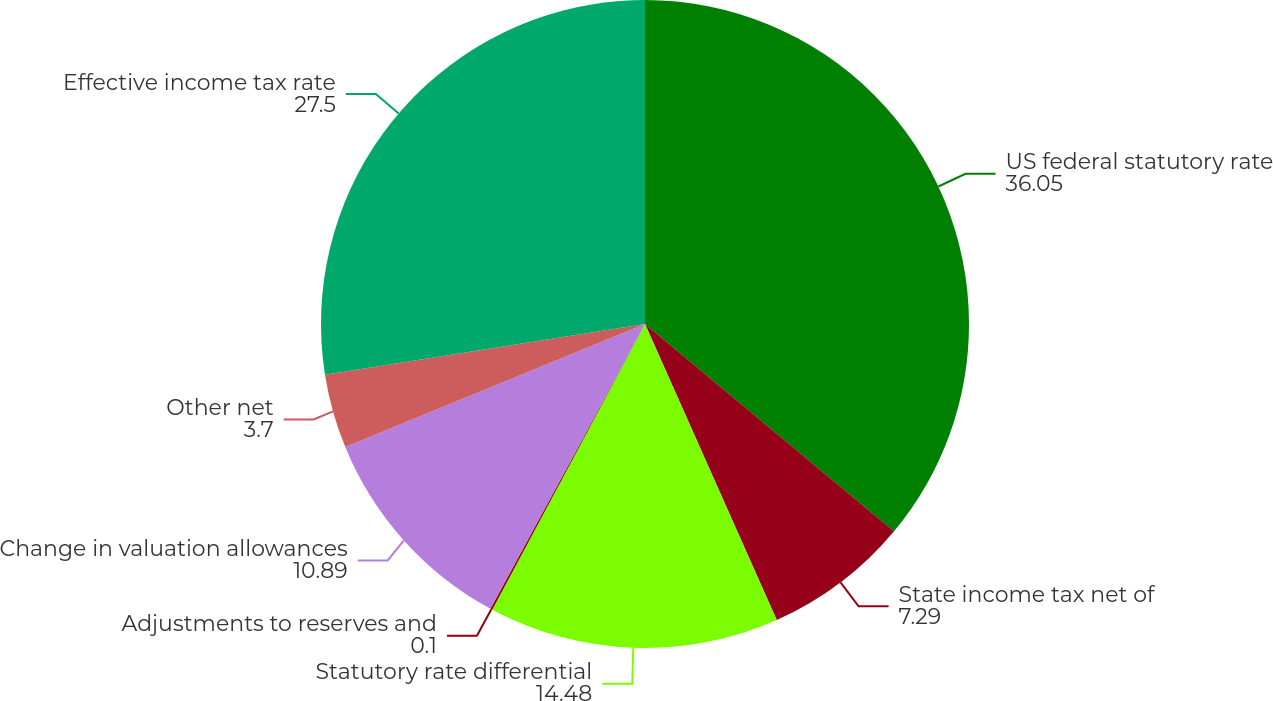Convert chart to OTSL. <chart><loc_0><loc_0><loc_500><loc_500><pie_chart><fcel>US federal statutory rate<fcel>State income tax net of<fcel>Statutory rate differential<fcel>Adjustments to reserves and<fcel>Change in valuation allowances<fcel>Other net<fcel>Effective income tax rate<nl><fcel>36.05%<fcel>7.29%<fcel>14.48%<fcel>0.1%<fcel>10.89%<fcel>3.7%<fcel>27.5%<nl></chart> 